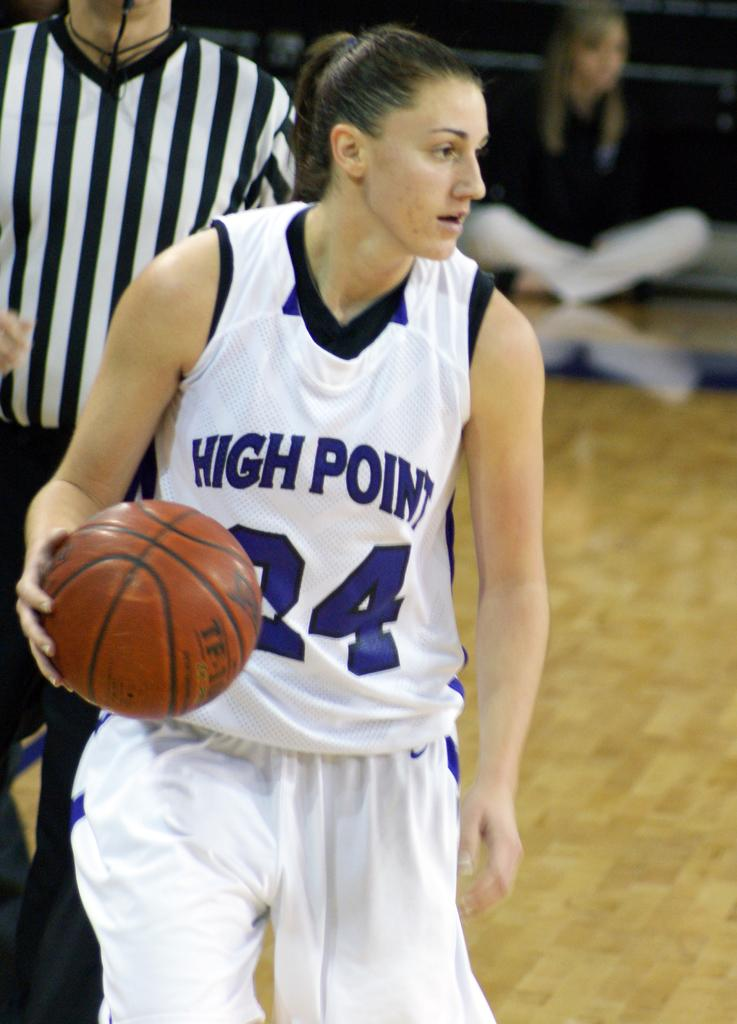<image>
Present a compact description of the photo's key features. a lady in a jersey that has High Point on it 